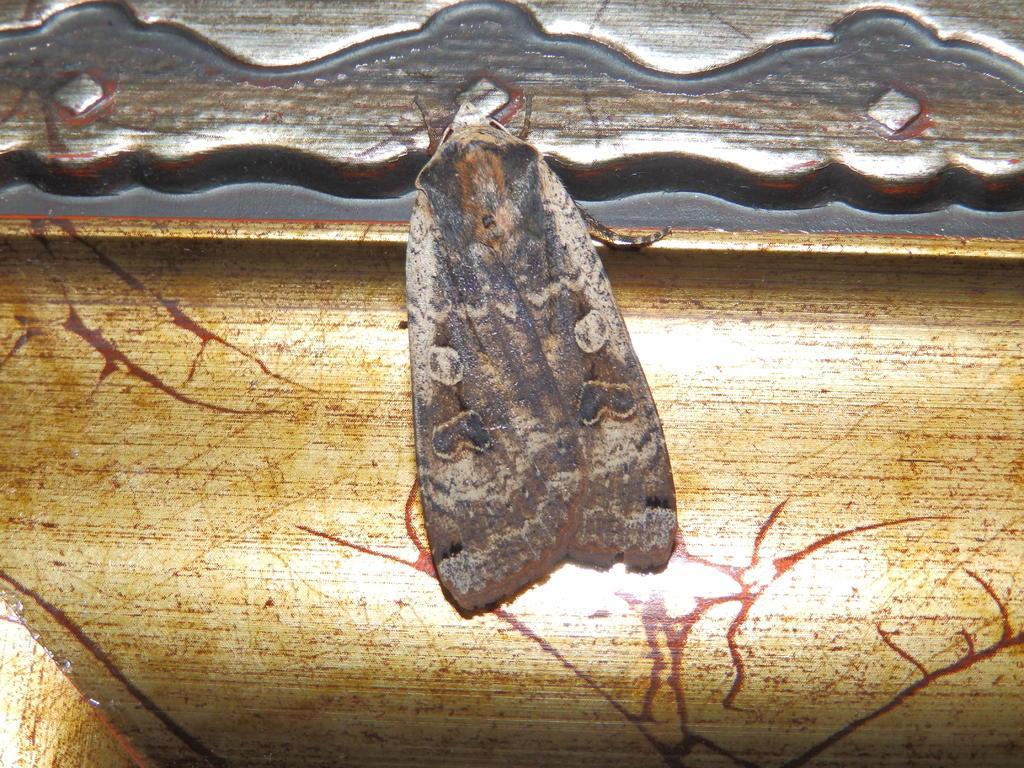How would you summarize this image in a sentence or two? In this image I can see an insect which is cream, brown and black in color on the object which is brown, cream and silver in color. 